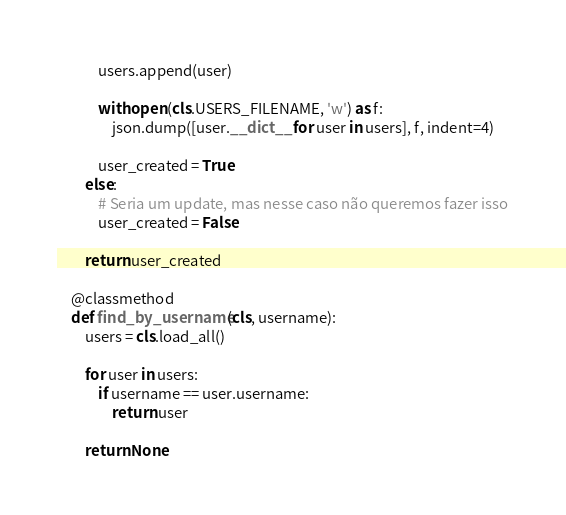<code> <loc_0><loc_0><loc_500><loc_500><_Python_>            users.append(user)

            with open(cls.USERS_FILENAME, 'w') as f:
                json.dump([user.__dict__ for user in users], f, indent=4)

            user_created = True
        else:
            # Seria um update, mas nesse caso não queremos fazer isso
            user_created = False
        
        return user_created

    @classmethod
    def find_by_username(cls, username):
        users = cls.load_all()

        for user in users:
            if username == user.username:
                return user

        return None</code> 